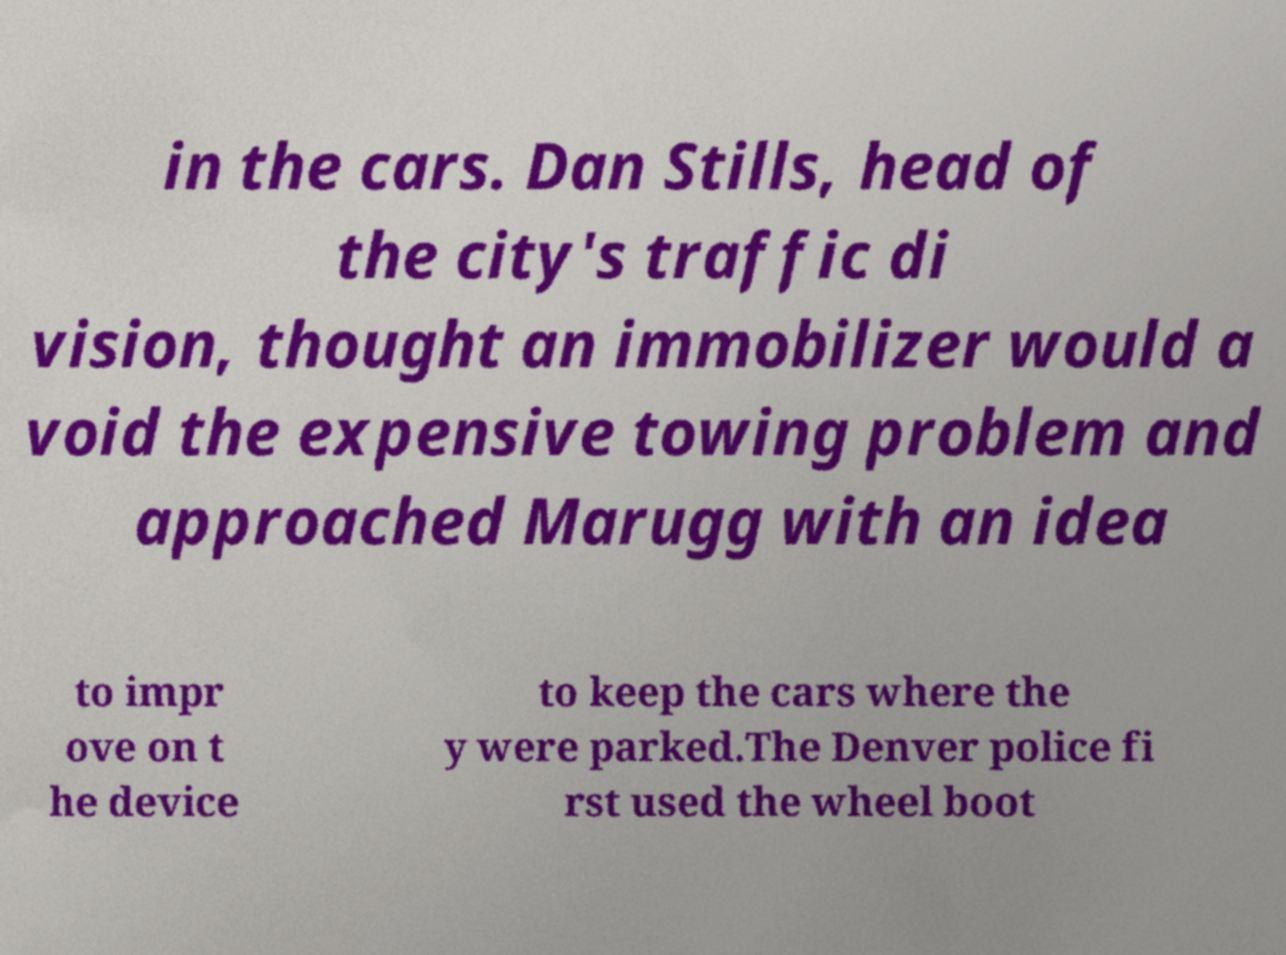Please read and relay the text visible in this image. What does it say? in the cars. Dan Stills, head of the city's traffic di vision, thought an immobilizer would a void the expensive towing problem and approached Marugg with an idea to impr ove on t he device to keep the cars where the y were parked.The Denver police fi rst used the wheel boot 